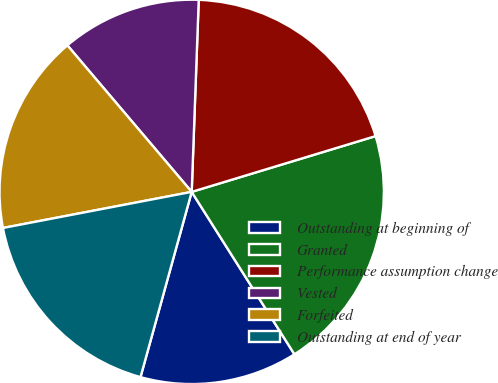<chart> <loc_0><loc_0><loc_500><loc_500><pie_chart><fcel>Outstanding at beginning of<fcel>Granted<fcel>Performance assumption change<fcel>Vested<fcel>Forfeited<fcel>Outstanding at end of year<nl><fcel>13.27%<fcel>20.71%<fcel>19.73%<fcel>11.78%<fcel>16.81%<fcel>17.7%<nl></chart> 